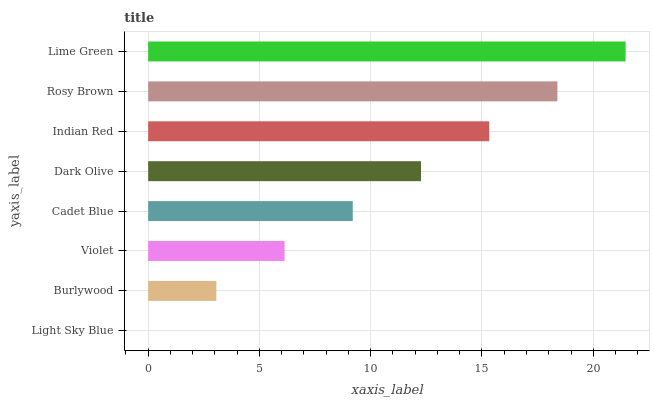Is Light Sky Blue the minimum?
Answer yes or no. Yes. Is Lime Green the maximum?
Answer yes or no. Yes. Is Burlywood the minimum?
Answer yes or no. No. Is Burlywood the maximum?
Answer yes or no. No. Is Burlywood greater than Light Sky Blue?
Answer yes or no. Yes. Is Light Sky Blue less than Burlywood?
Answer yes or no. Yes. Is Light Sky Blue greater than Burlywood?
Answer yes or no. No. Is Burlywood less than Light Sky Blue?
Answer yes or no. No. Is Dark Olive the high median?
Answer yes or no. Yes. Is Cadet Blue the low median?
Answer yes or no. Yes. Is Violet the high median?
Answer yes or no. No. Is Lime Green the low median?
Answer yes or no. No. 